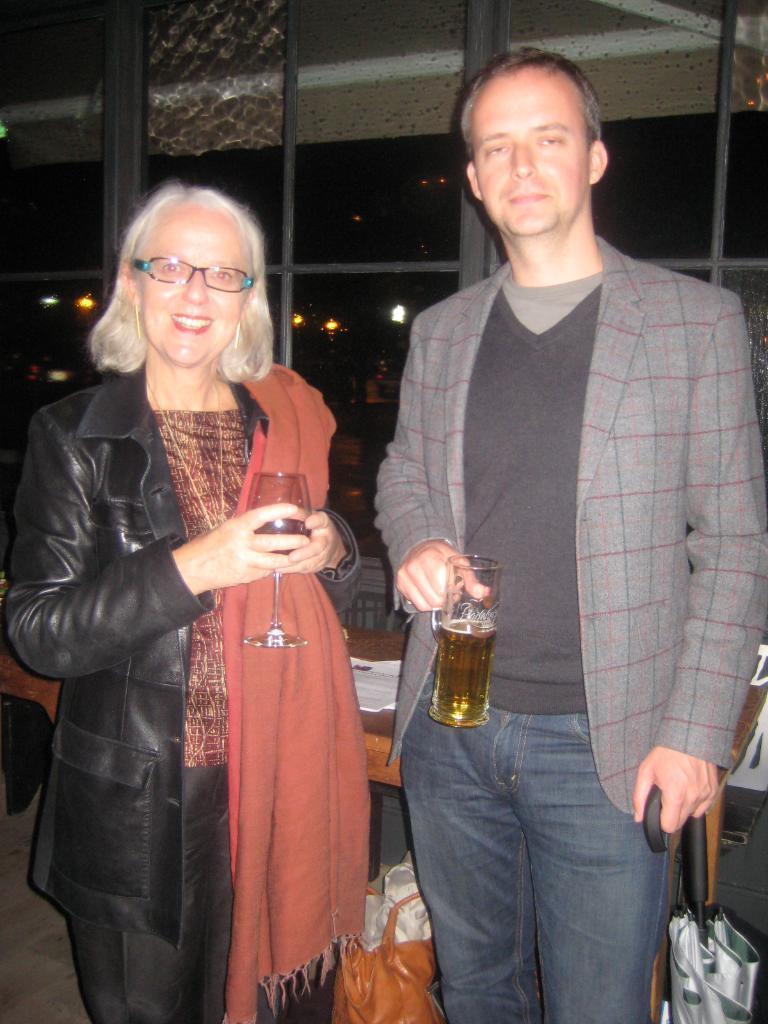In one or two sentences, can you explain what this image depicts? This picture is clicked inside. In the foreground we can see a man wearing blazer, holding an umbrella and a glass of drink and standing. On the left there is a woman wearing black color jacket, smiling, holding a glass of drink and standing. In the background there is a table on the top of which some items are placed and there are some items placed on the ground. In the background we can see the windows and through the windows we can see the lights and the roof and some other objects. 